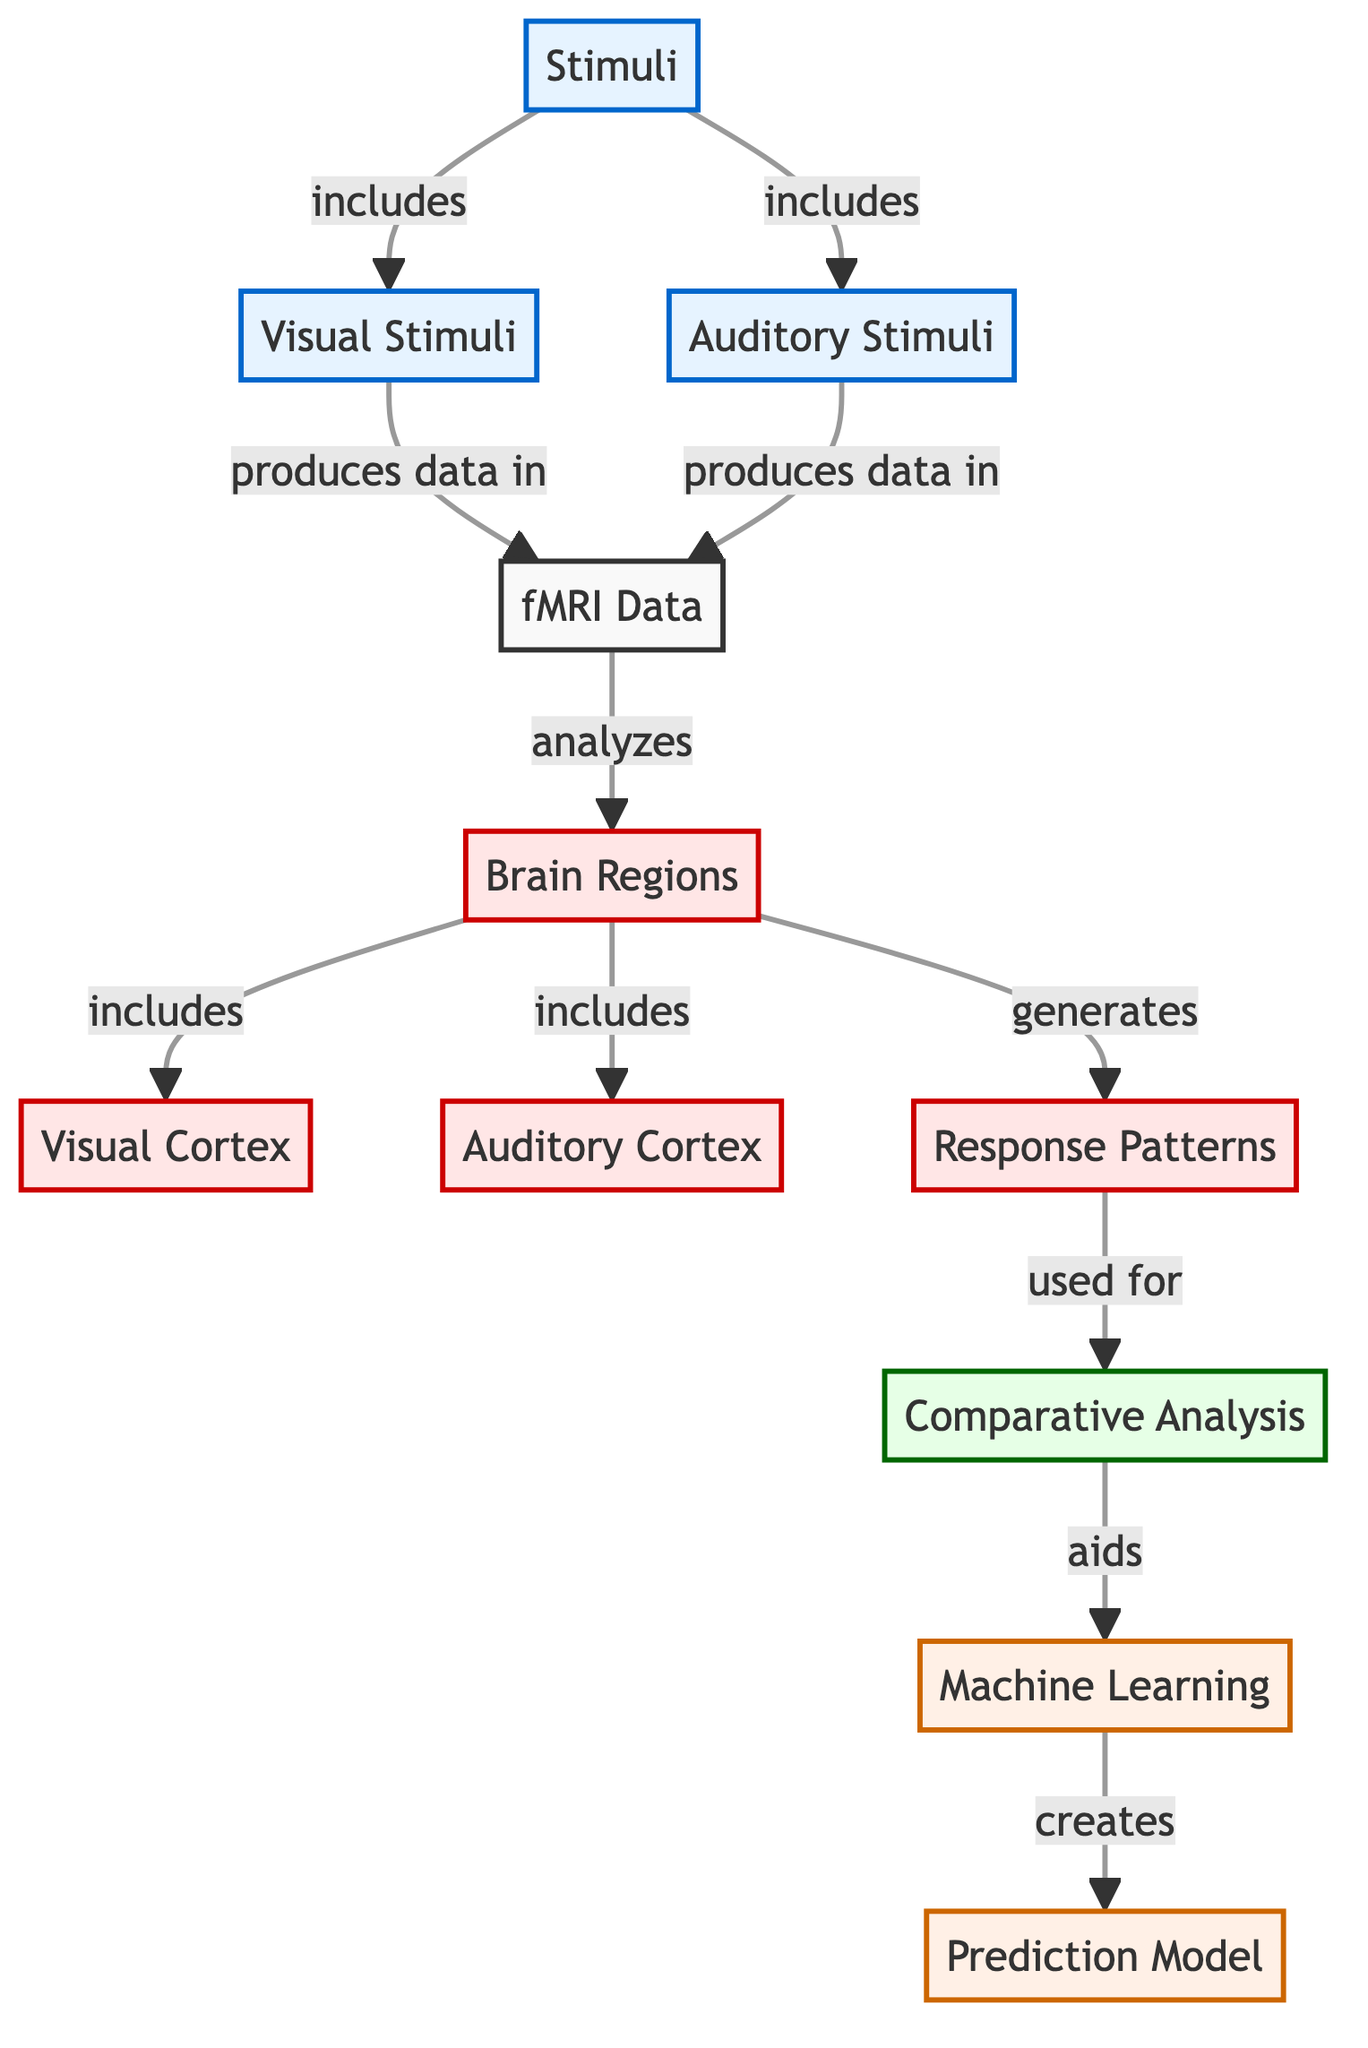What are the types of stimuli included in the diagram? The diagram mentions two types of stimuli: visual stimuli and auditory stimuli, both classified under the "Stimuli" node.
Answer: visual stimuli, auditory stimuli How many brain regions are analyzed in the diagram? The diagram indicates that there are two brain regions specifically mentioned: visual cortex and auditory cortex. Hence, the total is two brain regions.
Answer: two What does fMRI data analyze? The fMRI data is shown to analyze brain regions, which are derived from both visual and auditory stimuli. This establishes a direct relationship from fMRI data to the analysis of brain regions.
Answer: brain regions Which node generates response patterns? The response patterns node is generated from the brain regions in the diagram. The arrow indicates a direct flow from brain regions to response patterns.
Answer: brain regions How does machine learning relate to comparative analysis? The diagram illustrates that comparative analysis aids machine learning, establishing a functional relationship where comparative analysis is a contributor to machine learning.
Answer: aids What is the outcome of the flow from auditory stimuli? The flowchart shows that auditory stimuli produce data in fMRI data, which leads to analyzing brain regions and further generating response patterns. Therefore, the outcome flows through those nodes, ending at comparative analysis.
Answer: fMRI data What color is used to represent the analysis nodes in the diagram? The analysis nodes, including comparative analysis, are colored light green (#e6ffe6), differentiating them from other categories represented in the diagram.
Answer: light green How are visual stimuli connected to fMRI data? The diagram shows a direct link where visual stimuli produces data in fMRI data. This specific relationship indicates that visual stimuli directly affect fMRI data generation.
Answer: produces data in What creates the prediction model in the diagram? The prediction model is created through the machine learning node, which relies on the preceding comparative analysis indicated by the flow. Thus, it is reliant on comparative analysis for its creation.
Answer: machine learning 